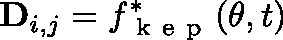Convert formula to latex. <formula><loc_0><loc_0><loc_500><loc_500>D _ { i , j } = f _ { k e p } ^ { * } ( \theta , t )</formula> 